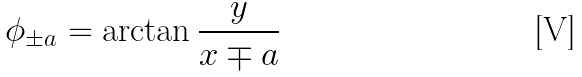Convert formula to latex. <formula><loc_0><loc_0><loc_500><loc_500>\phi _ { \pm a } = \arctan \frac { y } { x \mp a }</formula> 